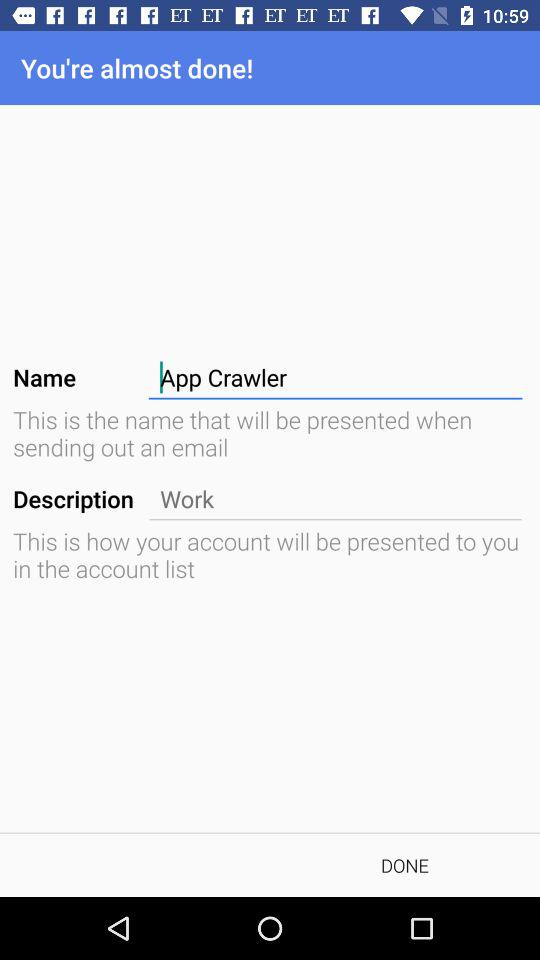What is the description name of my account?
When the provided information is insufficient, respond with <no answer>. <no answer> 